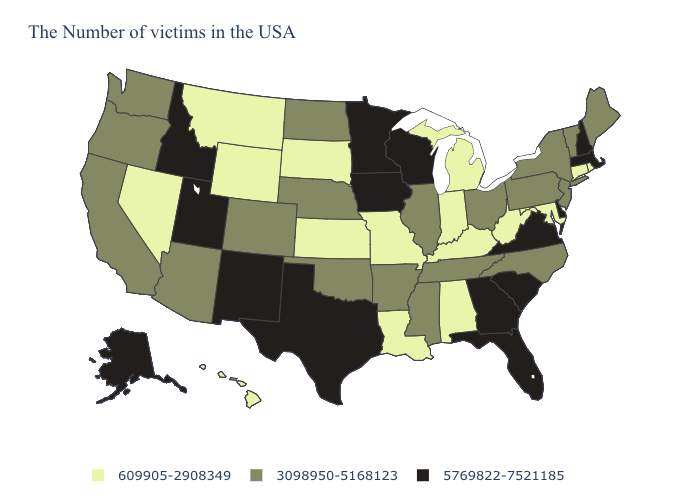Which states hav the highest value in the South?
Write a very short answer. Delaware, Virginia, South Carolina, Florida, Georgia, Texas. What is the value of Louisiana?
Concise answer only. 609905-2908349. Name the states that have a value in the range 609905-2908349?
Keep it brief. Rhode Island, Connecticut, Maryland, West Virginia, Michigan, Kentucky, Indiana, Alabama, Louisiana, Missouri, Kansas, South Dakota, Wyoming, Montana, Nevada, Hawaii. Does Connecticut have the same value as Michigan?
Answer briefly. Yes. What is the lowest value in the MidWest?
Quick response, please. 609905-2908349. Which states have the highest value in the USA?
Keep it brief. Massachusetts, New Hampshire, Delaware, Virginia, South Carolina, Florida, Georgia, Wisconsin, Minnesota, Iowa, Texas, New Mexico, Utah, Idaho, Alaska. Name the states that have a value in the range 5769822-7521185?
Concise answer only. Massachusetts, New Hampshire, Delaware, Virginia, South Carolina, Florida, Georgia, Wisconsin, Minnesota, Iowa, Texas, New Mexico, Utah, Idaho, Alaska. What is the highest value in states that border Maryland?
Keep it brief. 5769822-7521185. What is the value of West Virginia?
Quick response, please. 609905-2908349. Does Colorado have the highest value in the West?
Give a very brief answer. No. Which states have the lowest value in the Northeast?
Give a very brief answer. Rhode Island, Connecticut. Does Maryland have a higher value than New Hampshire?
Be succinct. No. Name the states that have a value in the range 609905-2908349?
Keep it brief. Rhode Island, Connecticut, Maryland, West Virginia, Michigan, Kentucky, Indiana, Alabama, Louisiana, Missouri, Kansas, South Dakota, Wyoming, Montana, Nevada, Hawaii. Name the states that have a value in the range 3098950-5168123?
Answer briefly. Maine, Vermont, New York, New Jersey, Pennsylvania, North Carolina, Ohio, Tennessee, Illinois, Mississippi, Arkansas, Nebraska, Oklahoma, North Dakota, Colorado, Arizona, California, Washington, Oregon. What is the highest value in the USA?
Keep it brief. 5769822-7521185. 